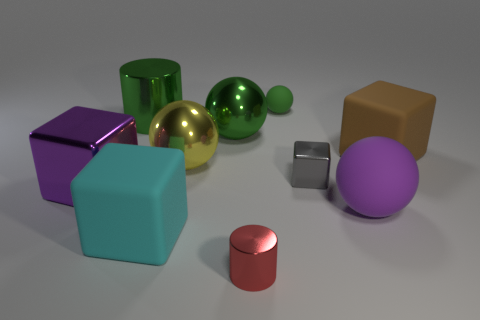Subtract 1 balls. How many balls are left? 3 Subtract all large purple blocks. How many blocks are left? 3 Subtract all yellow spheres. How many spheres are left? 3 Subtract all brown balls. Subtract all brown cylinders. How many balls are left? 4 Subtract all blocks. How many objects are left? 6 Subtract 1 red cylinders. How many objects are left? 9 Subtract all tiny red metallic cylinders. Subtract all small red things. How many objects are left? 8 Add 6 red objects. How many red objects are left? 7 Add 3 large purple blocks. How many large purple blocks exist? 4 